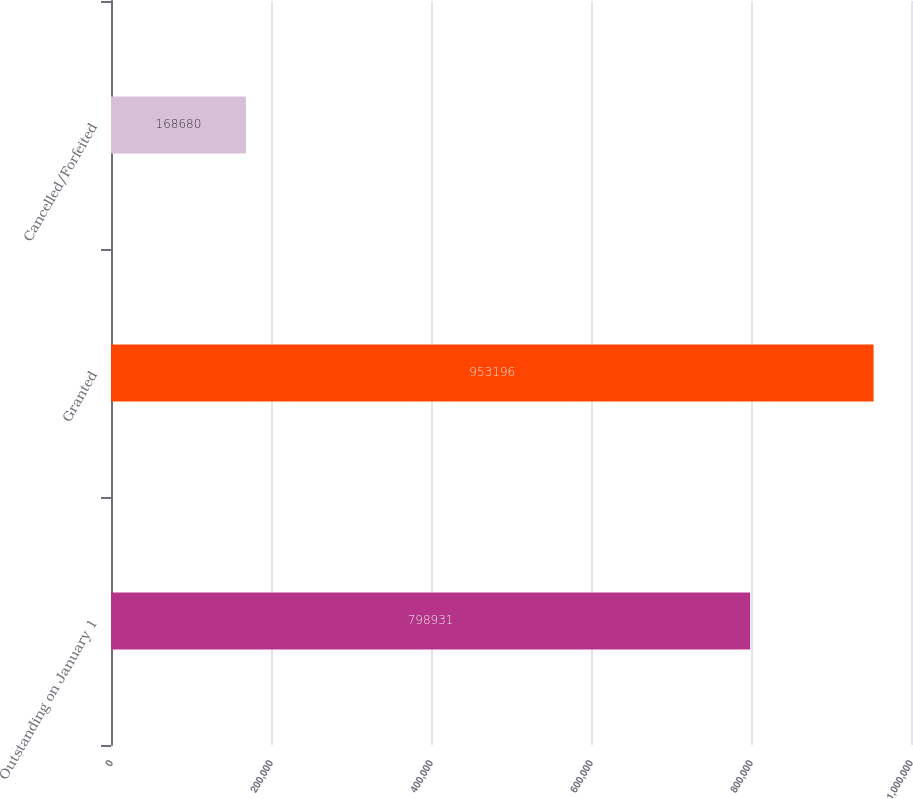Convert chart. <chart><loc_0><loc_0><loc_500><loc_500><bar_chart><fcel>Outstanding on January 1<fcel>Granted<fcel>Cancelled/Forfeited<nl><fcel>798931<fcel>953196<fcel>168680<nl></chart> 